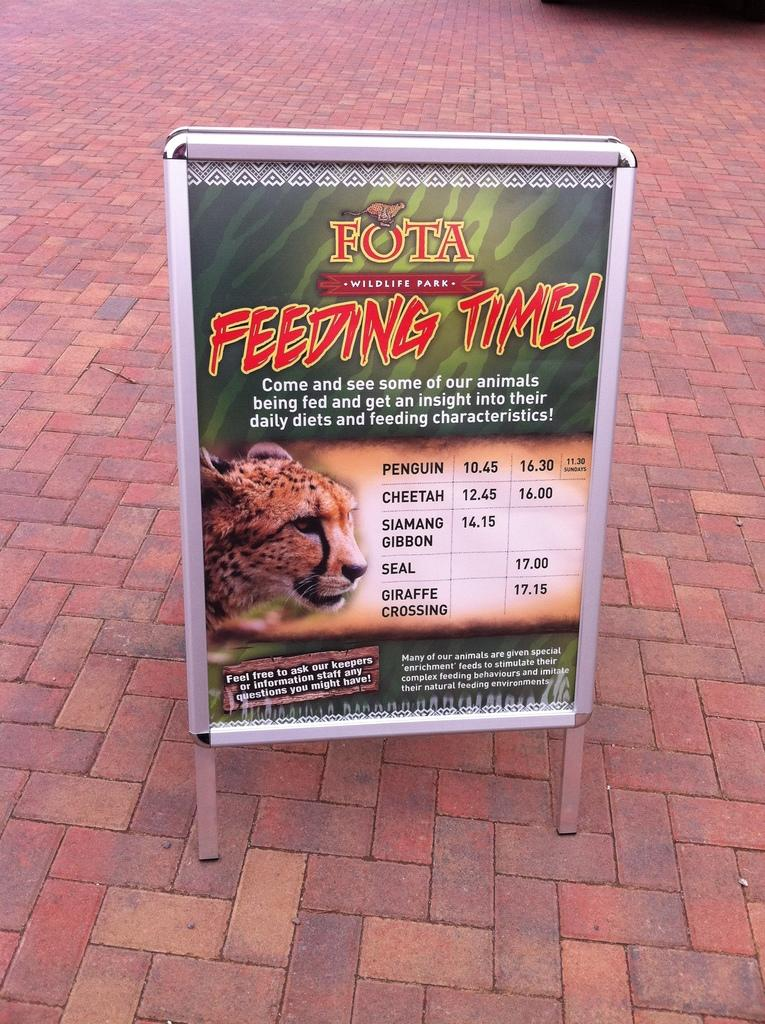What is the main object in the image? There is a board in the image. Where is the board located? The board is on a surface. What design is on the board? There is a tiger face on the board. What can be found on the board besides the tiger face? There is information on the board. How does the goose interact with the door in the image? There is no goose or door present in the image. 